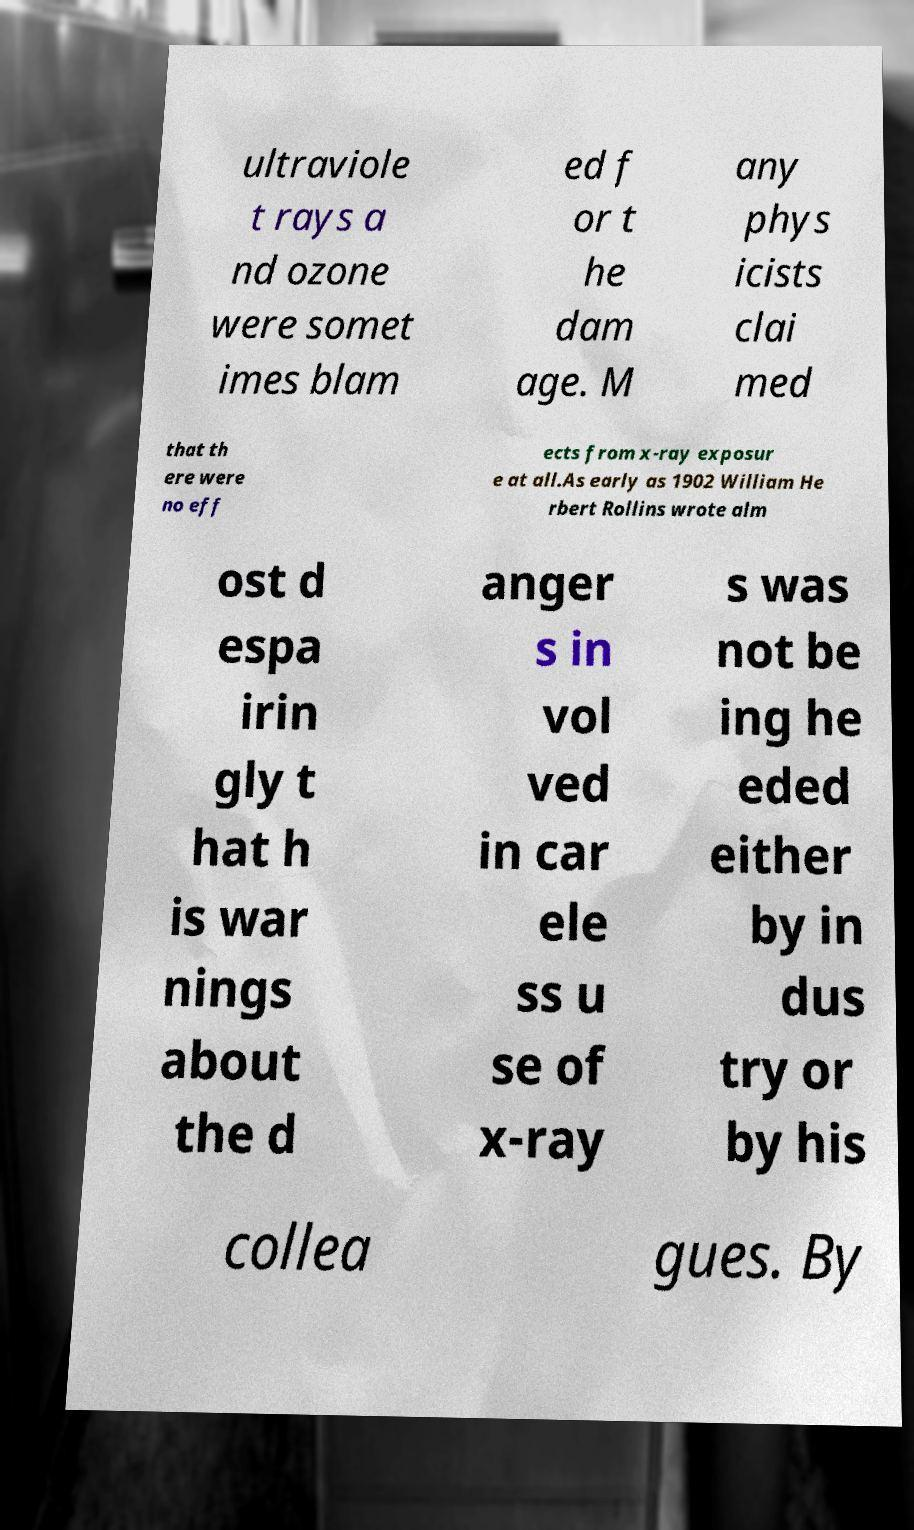What messages or text are displayed in this image? I need them in a readable, typed format. ultraviole t rays a nd ozone were somet imes blam ed f or t he dam age. M any phys icists clai med that th ere were no eff ects from x-ray exposur e at all.As early as 1902 William He rbert Rollins wrote alm ost d espa irin gly t hat h is war nings about the d anger s in vol ved in car ele ss u se of x-ray s was not be ing he eded either by in dus try or by his collea gues. By 